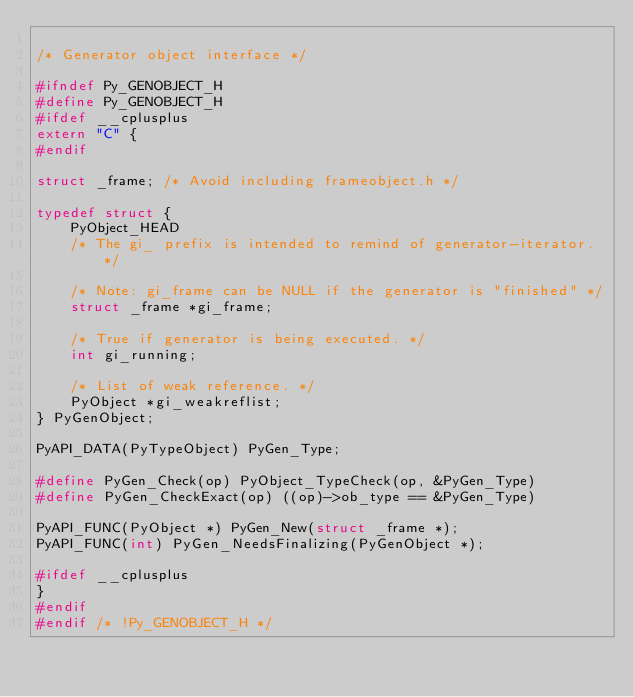Convert code to text. <code><loc_0><loc_0><loc_500><loc_500><_C_>
/* Generator object interface */

#ifndef Py_GENOBJECT_H
#define Py_GENOBJECT_H
#ifdef __cplusplus
extern "C" {
#endif

struct _frame; /* Avoid including frameobject.h */

typedef struct {
	PyObject_HEAD
	/* The gi_ prefix is intended to remind of generator-iterator. */

	/* Note: gi_frame can be NULL if the generator is "finished" */
	struct _frame *gi_frame;

	/* True if generator is being executed. */
	int gi_running;

	/* List of weak reference. */
	PyObject *gi_weakreflist;
} PyGenObject;

PyAPI_DATA(PyTypeObject) PyGen_Type;

#define PyGen_Check(op) PyObject_TypeCheck(op, &PyGen_Type)
#define PyGen_CheckExact(op) ((op)->ob_type == &PyGen_Type)

PyAPI_FUNC(PyObject *) PyGen_New(struct _frame *);
PyAPI_FUNC(int) PyGen_NeedsFinalizing(PyGenObject *);

#ifdef __cplusplus
}
#endif
#endif /* !Py_GENOBJECT_H */
</code> 